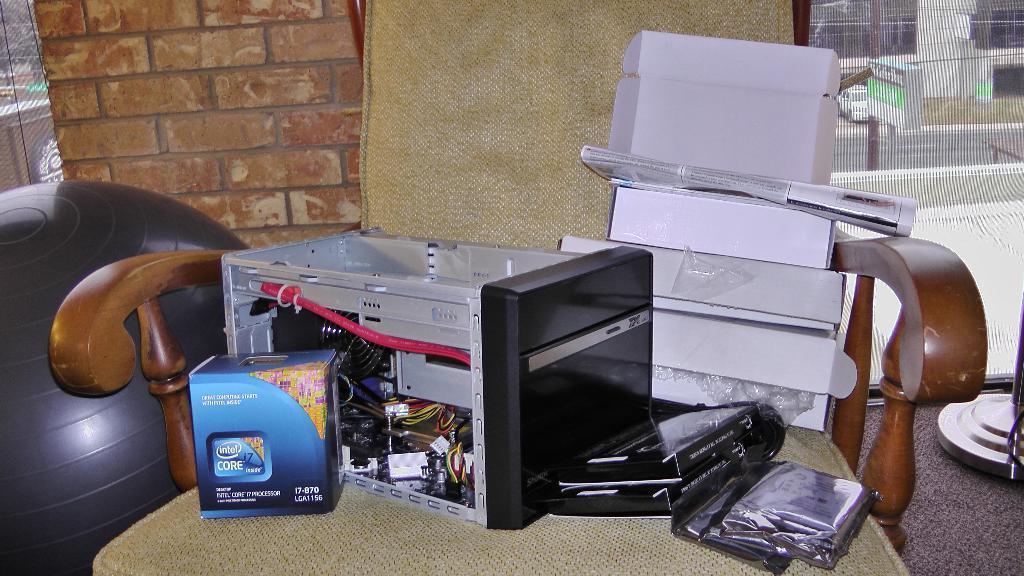What is the main subject in the center of the image? There are books in the center of the image. What can be said about the books in the image? Some of the books are printed. What is placed on the chair in the image? There are objects placed on a chair. What can be seen in the background of the image? There is an exercise ball, a wall, a vehicle, a road, and a building in the background. What type of vessel is being used to transport the drug in the image? There is no vessel or drug present in the image. What causes the spark in the image? There is no spark present in the image. 